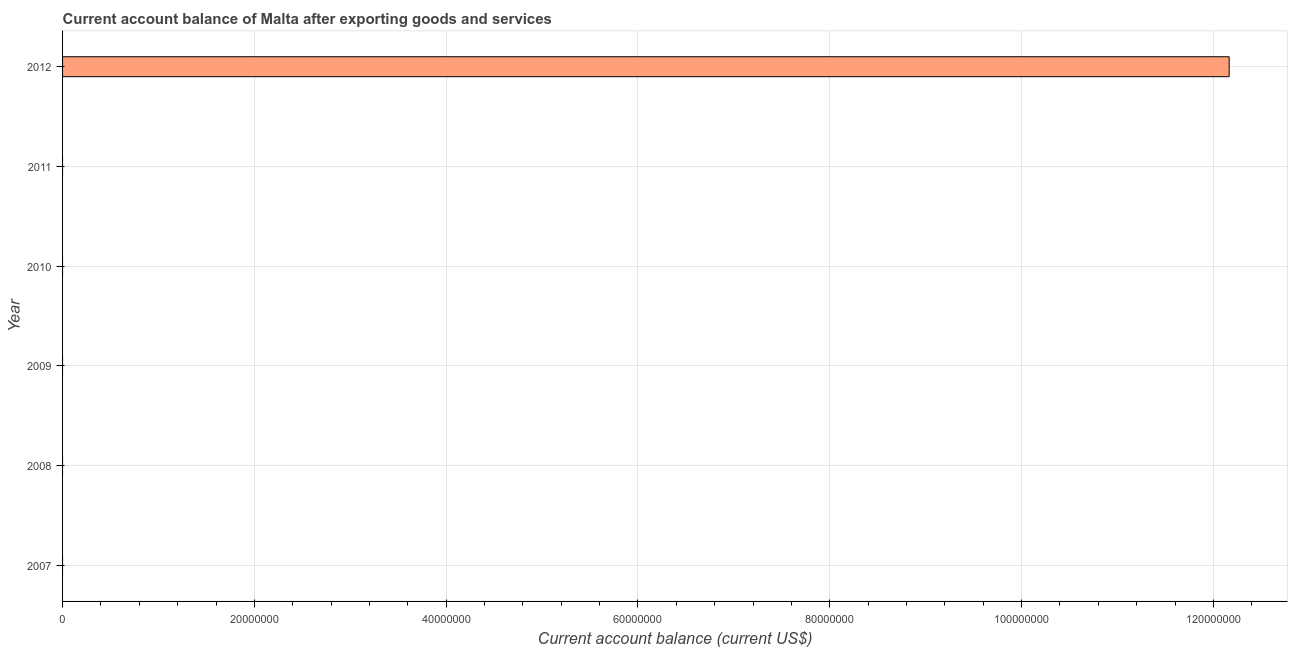Does the graph contain grids?
Provide a succinct answer. Yes. What is the title of the graph?
Offer a very short reply. Current account balance of Malta after exporting goods and services. What is the label or title of the X-axis?
Provide a short and direct response. Current account balance (current US$). What is the current account balance in 2009?
Ensure brevity in your answer.  0. Across all years, what is the maximum current account balance?
Make the answer very short. 1.22e+08. Across all years, what is the minimum current account balance?
Ensure brevity in your answer.  0. What is the sum of the current account balance?
Provide a short and direct response. 1.22e+08. What is the average current account balance per year?
Give a very brief answer. 2.03e+07. In how many years, is the current account balance greater than 36000000 US$?
Give a very brief answer. 1. What is the difference between the highest and the lowest current account balance?
Your answer should be very brief. 1.22e+08. In how many years, is the current account balance greater than the average current account balance taken over all years?
Make the answer very short. 1. How many bars are there?
Offer a very short reply. 1. What is the difference between two consecutive major ticks on the X-axis?
Provide a succinct answer. 2.00e+07. Are the values on the major ticks of X-axis written in scientific E-notation?
Make the answer very short. No. What is the Current account balance (current US$) in 2007?
Keep it short and to the point. 0. What is the Current account balance (current US$) in 2010?
Provide a succinct answer. 0. What is the Current account balance (current US$) of 2011?
Keep it short and to the point. 0. What is the Current account balance (current US$) of 2012?
Ensure brevity in your answer.  1.22e+08. 